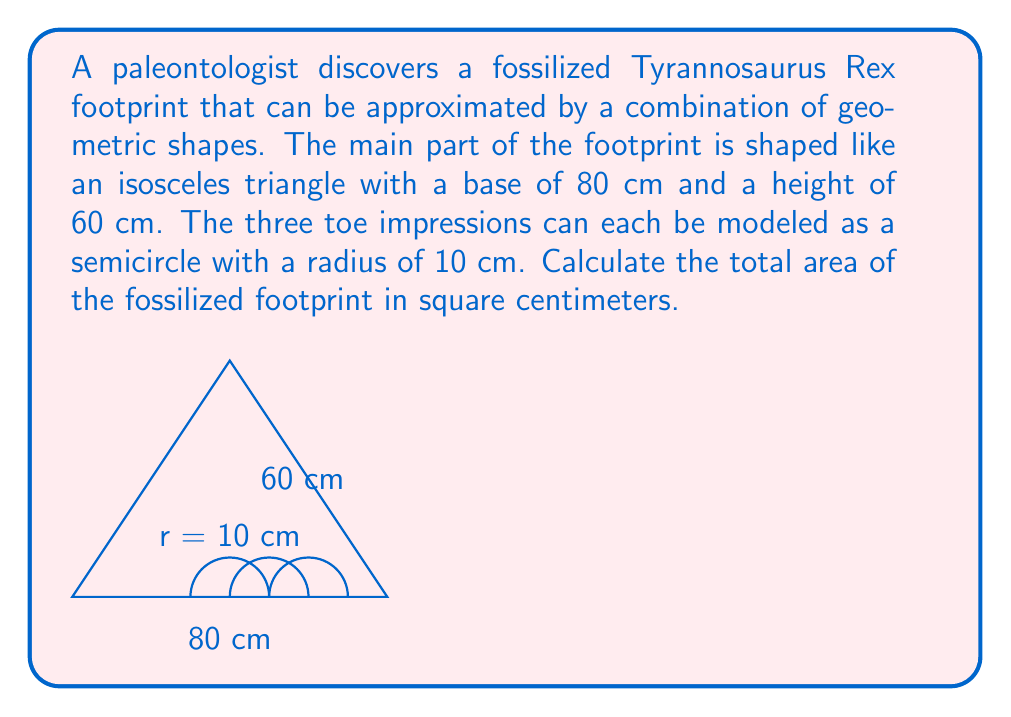Teach me how to tackle this problem. Let's break this problem down into steps:

1) First, calculate the area of the isosceles triangle:
   Area of triangle = $\frac{1}{2} \times base \times height$
   $A_{triangle} = \frac{1}{2} \times 80 \times 60 = 2400$ cm²

2) Now, calculate the area of one semicircle:
   Area of semicircle = $\frac{1}{2} \times \pi r^2$
   $A_{semicircle} = \frac{1}{2} \times \pi \times 10^2 = 50\pi$ cm²

3) There are three semicircles (toe impressions), so multiply by 3:
   Total area of semicircles = $3 \times 50\pi = 150\pi$ cm²

4) The total area of the footprint is the sum of the triangle area and the three semicircle areas:
   $A_{total} = A_{triangle} + 3 \times A_{semicircle}$
   $A_{total} = 2400 + 150\pi$ cm²

5) If we want to express this with π, we can leave it as is. If we want a decimal approximation:
   $A_{total} \approx 2400 + 150 \times 3.14159 \approx 2871.24$ cm²

Therefore, the total area of the fossilized footprint is $2400 + 150\pi$ cm² or approximately 2871.24 cm².
Answer: $2400 + 150\pi$ cm² (or approximately 2871.24 cm²) 